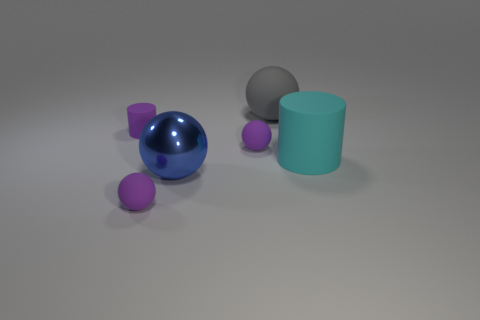Subtract all large gray matte balls. How many balls are left? 3 Subtract all spheres. How many objects are left? 2 Subtract all gray spheres. How many spheres are left? 3 Add 1 red metallic cubes. How many objects exist? 7 Subtract 0 red balls. How many objects are left? 6 Subtract all green cylinders. Subtract all cyan spheres. How many cylinders are left? 2 Subtract all red spheres. How many purple cylinders are left? 1 Subtract all big brown metallic blocks. Subtract all big cyan objects. How many objects are left? 5 Add 6 tiny rubber objects. How many tiny rubber objects are left? 9 Add 1 large rubber objects. How many large rubber objects exist? 3 